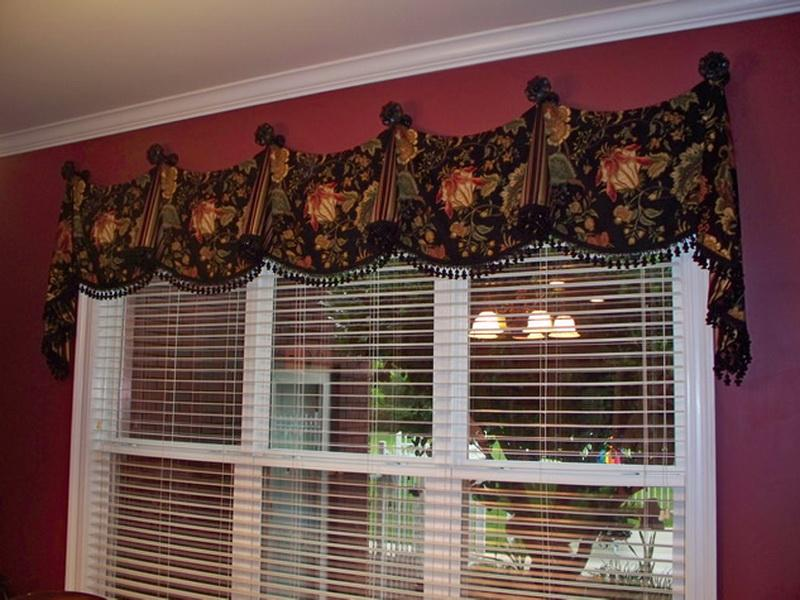If one were to redesign the space while keeping the window treatment, what changes would complement the existing aesthetic? To enhance the room while retaining the existing window treatment, one could introduce elements that echo its classic elegance. Incorporating furniture in dark wood tones with carved details would align with the traditional theme. Brass or gold accents, such as candlesticks or picture frames, could add a touch of luxury that complements the richness of the textiles. For lighting, a crystal chandelier or lamps with silk shades would meld well with the existing patterns and contribute to a cohesive, refined look. Finally, adding a Persian rug or other antique decorative objects would complete the transformation, ensuring a balanced marriage of opulence and taste. 